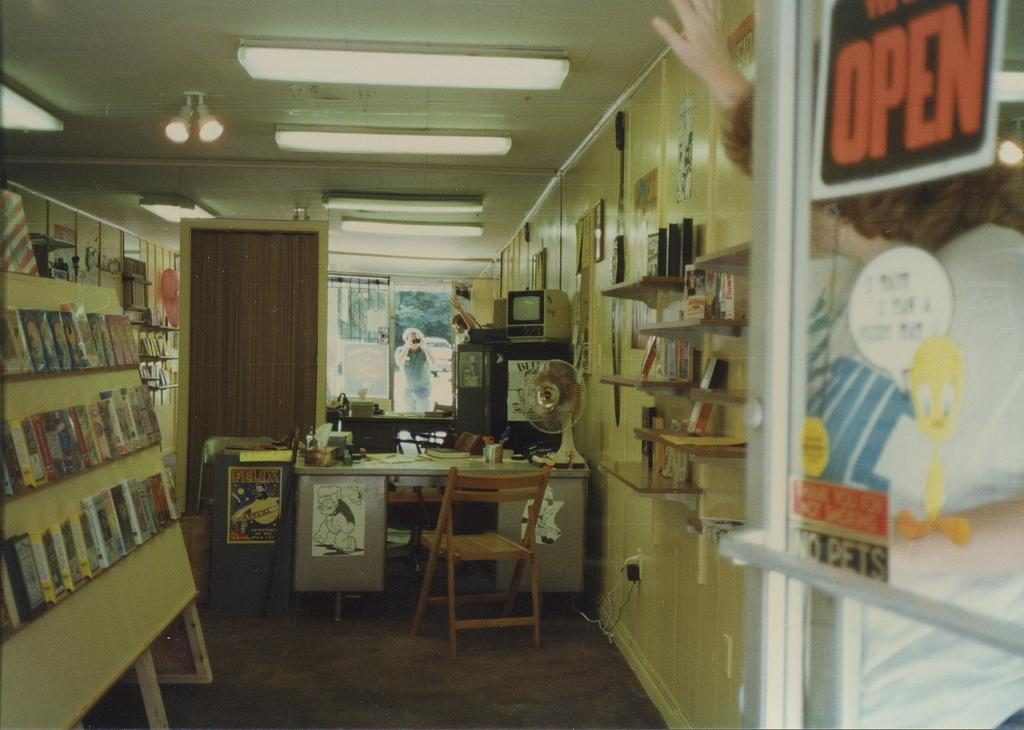<image>
Present a compact description of the photo's key features. A sign in a window reads open in orange lettering. 